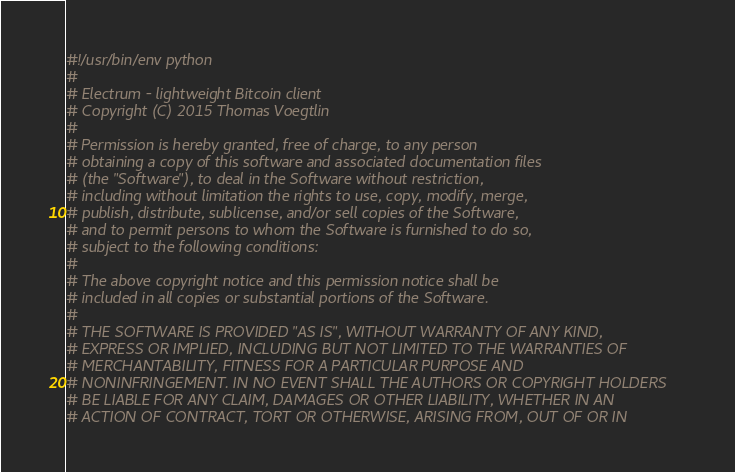Convert code to text. <code><loc_0><loc_0><loc_500><loc_500><_Python_>#!/usr/bin/env python
#
# Electrum - lightweight Bitcoin client
# Copyright (C) 2015 Thomas Voegtlin
#
# Permission is hereby granted, free of charge, to any person
# obtaining a copy of this software and associated documentation files
# (the "Software"), to deal in the Software without restriction,
# including without limitation the rights to use, copy, modify, merge,
# publish, distribute, sublicense, and/or sell copies of the Software,
# and to permit persons to whom the Software is furnished to do so,
# subject to the following conditions:
#
# The above copyright notice and this permission notice shall be
# included in all copies or substantial portions of the Software.
#
# THE SOFTWARE IS PROVIDED "AS IS", WITHOUT WARRANTY OF ANY KIND,
# EXPRESS OR IMPLIED, INCLUDING BUT NOT LIMITED TO THE WARRANTIES OF
# MERCHANTABILITY, FITNESS FOR A PARTICULAR PURPOSE AND
# NONINFRINGEMENT. IN NO EVENT SHALL THE AUTHORS OR COPYRIGHT HOLDERS
# BE LIABLE FOR ANY CLAIM, DAMAGES OR OTHER LIABILITY, WHETHER IN AN
# ACTION OF CONTRACT, TORT OR OTHERWISE, ARISING FROM, OUT OF OR IN</code> 